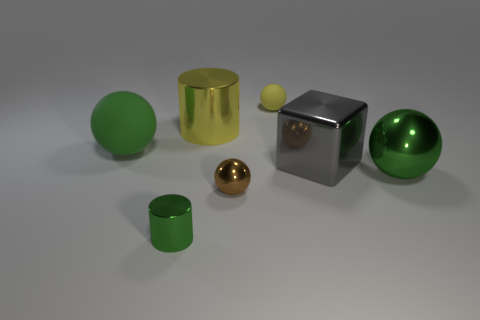What number of objects are tiny shiny things on the right side of the tiny green object or large cylinders?
Provide a succinct answer. 2. There is another thing that is the same color as the tiny matte thing; what is its material?
Ensure brevity in your answer.  Metal. There is a large object that is behind the large ball on the left side of the yellow sphere; are there any big green objects to the left of it?
Your response must be concise. Yes. Is the number of yellow metallic objects that are on the left side of the large green rubber object less than the number of small yellow matte spheres left of the small brown ball?
Your answer should be compact. No. There is a small sphere that is the same material as the big gray thing; what is its color?
Keep it short and to the point. Brown. There is a rubber ball in front of the tiny thing that is behind the large green matte sphere; what color is it?
Keep it short and to the point. Green. Is there a thing of the same color as the small rubber sphere?
Keep it short and to the point. Yes. The yellow thing that is the same size as the gray metallic thing is what shape?
Your answer should be very brief. Cylinder. There is a cylinder that is behind the large shiny sphere; how many green things are on the left side of it?
Your answer should be compact. 2. Does the big metal cube have the same color as the big matte object?
Offer a very short reply. No. 